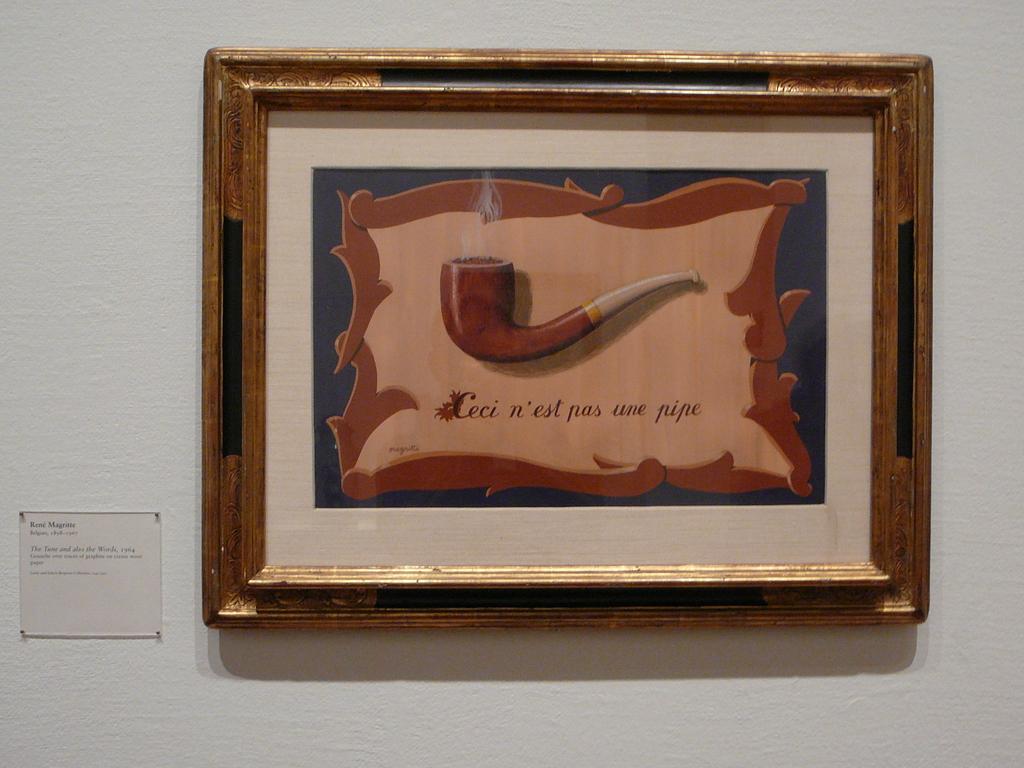What does it say in french?
Your answer should be very brief. Ceci n'est pas une pipe. 